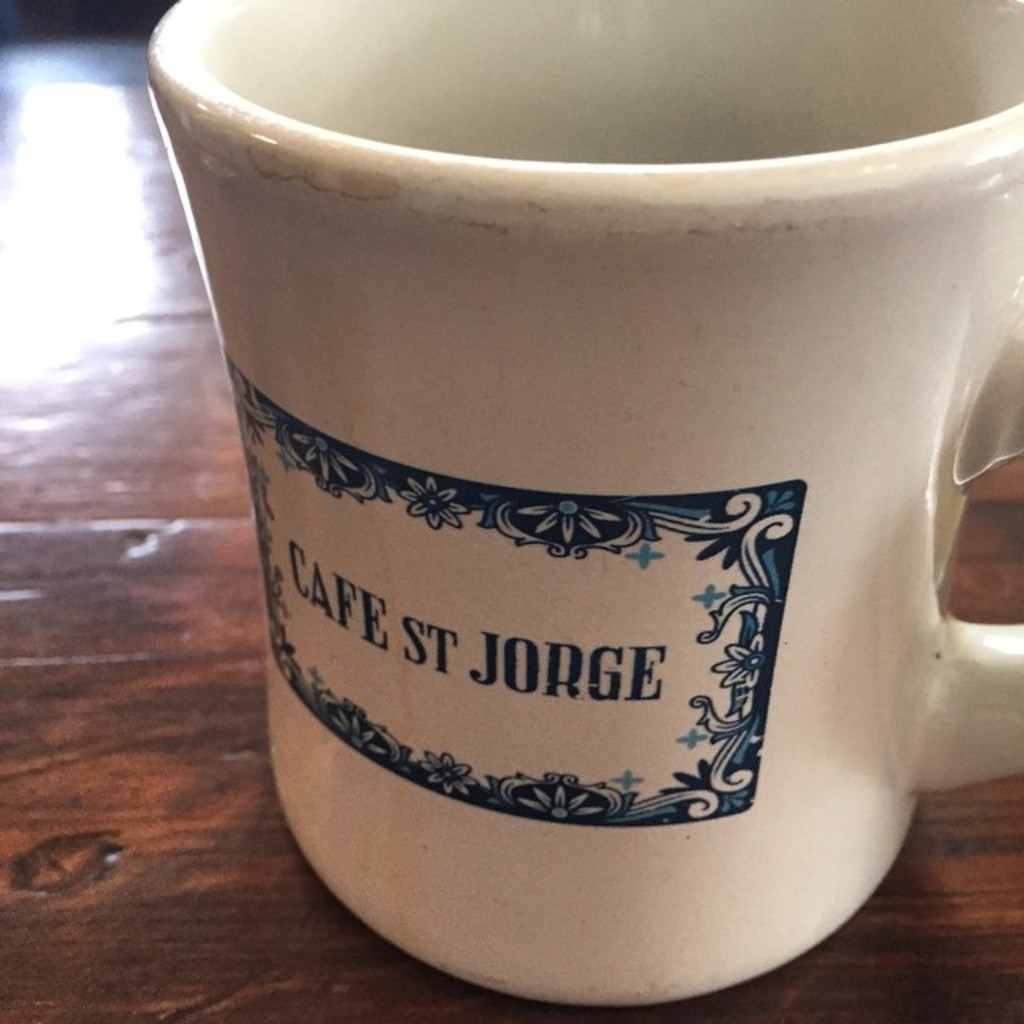Describe the design style of the mug shown in the image. The mug features a classic, rustic design with a creamy white background and a traditional blue floral pattern that borders the name 'Cafe ST Jorge,' hinting at a vintage European influence. 